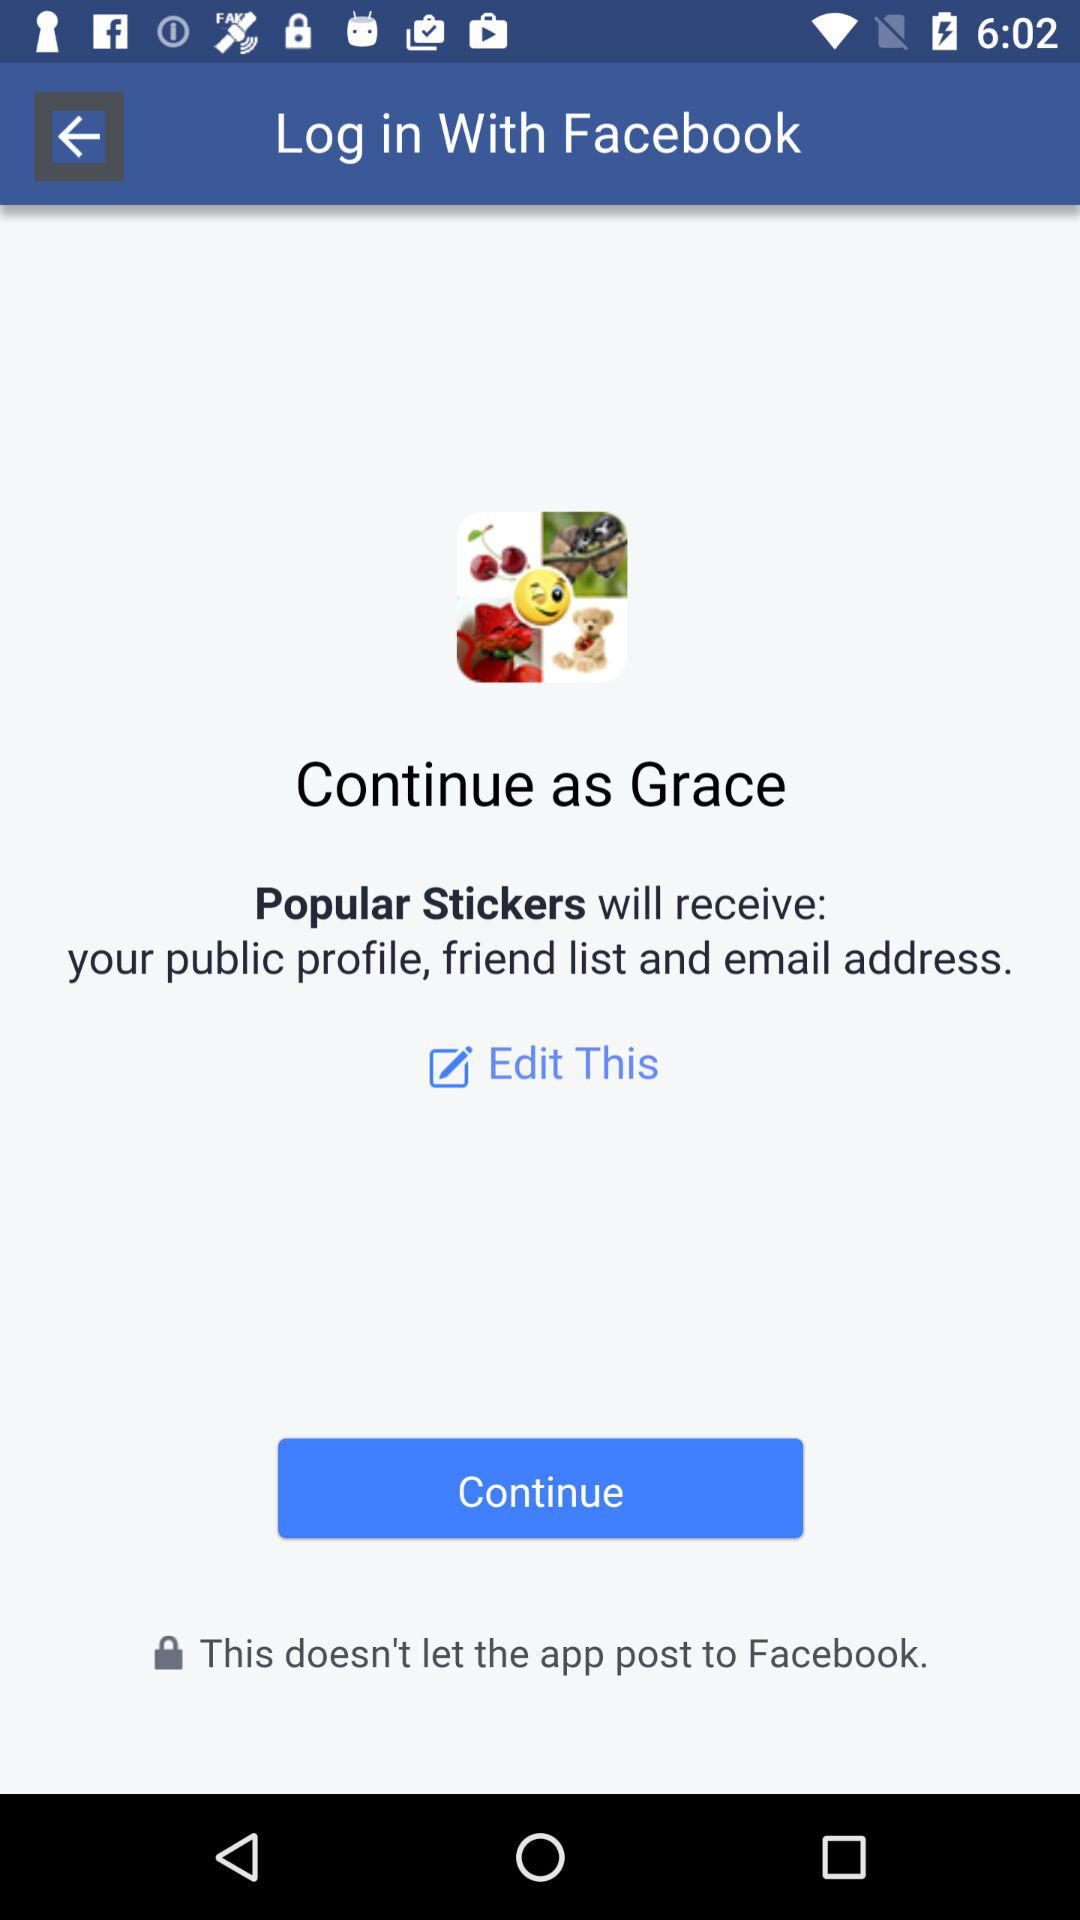What application is asking for permission? The application that is asking for permission is "Popular Stickers". 